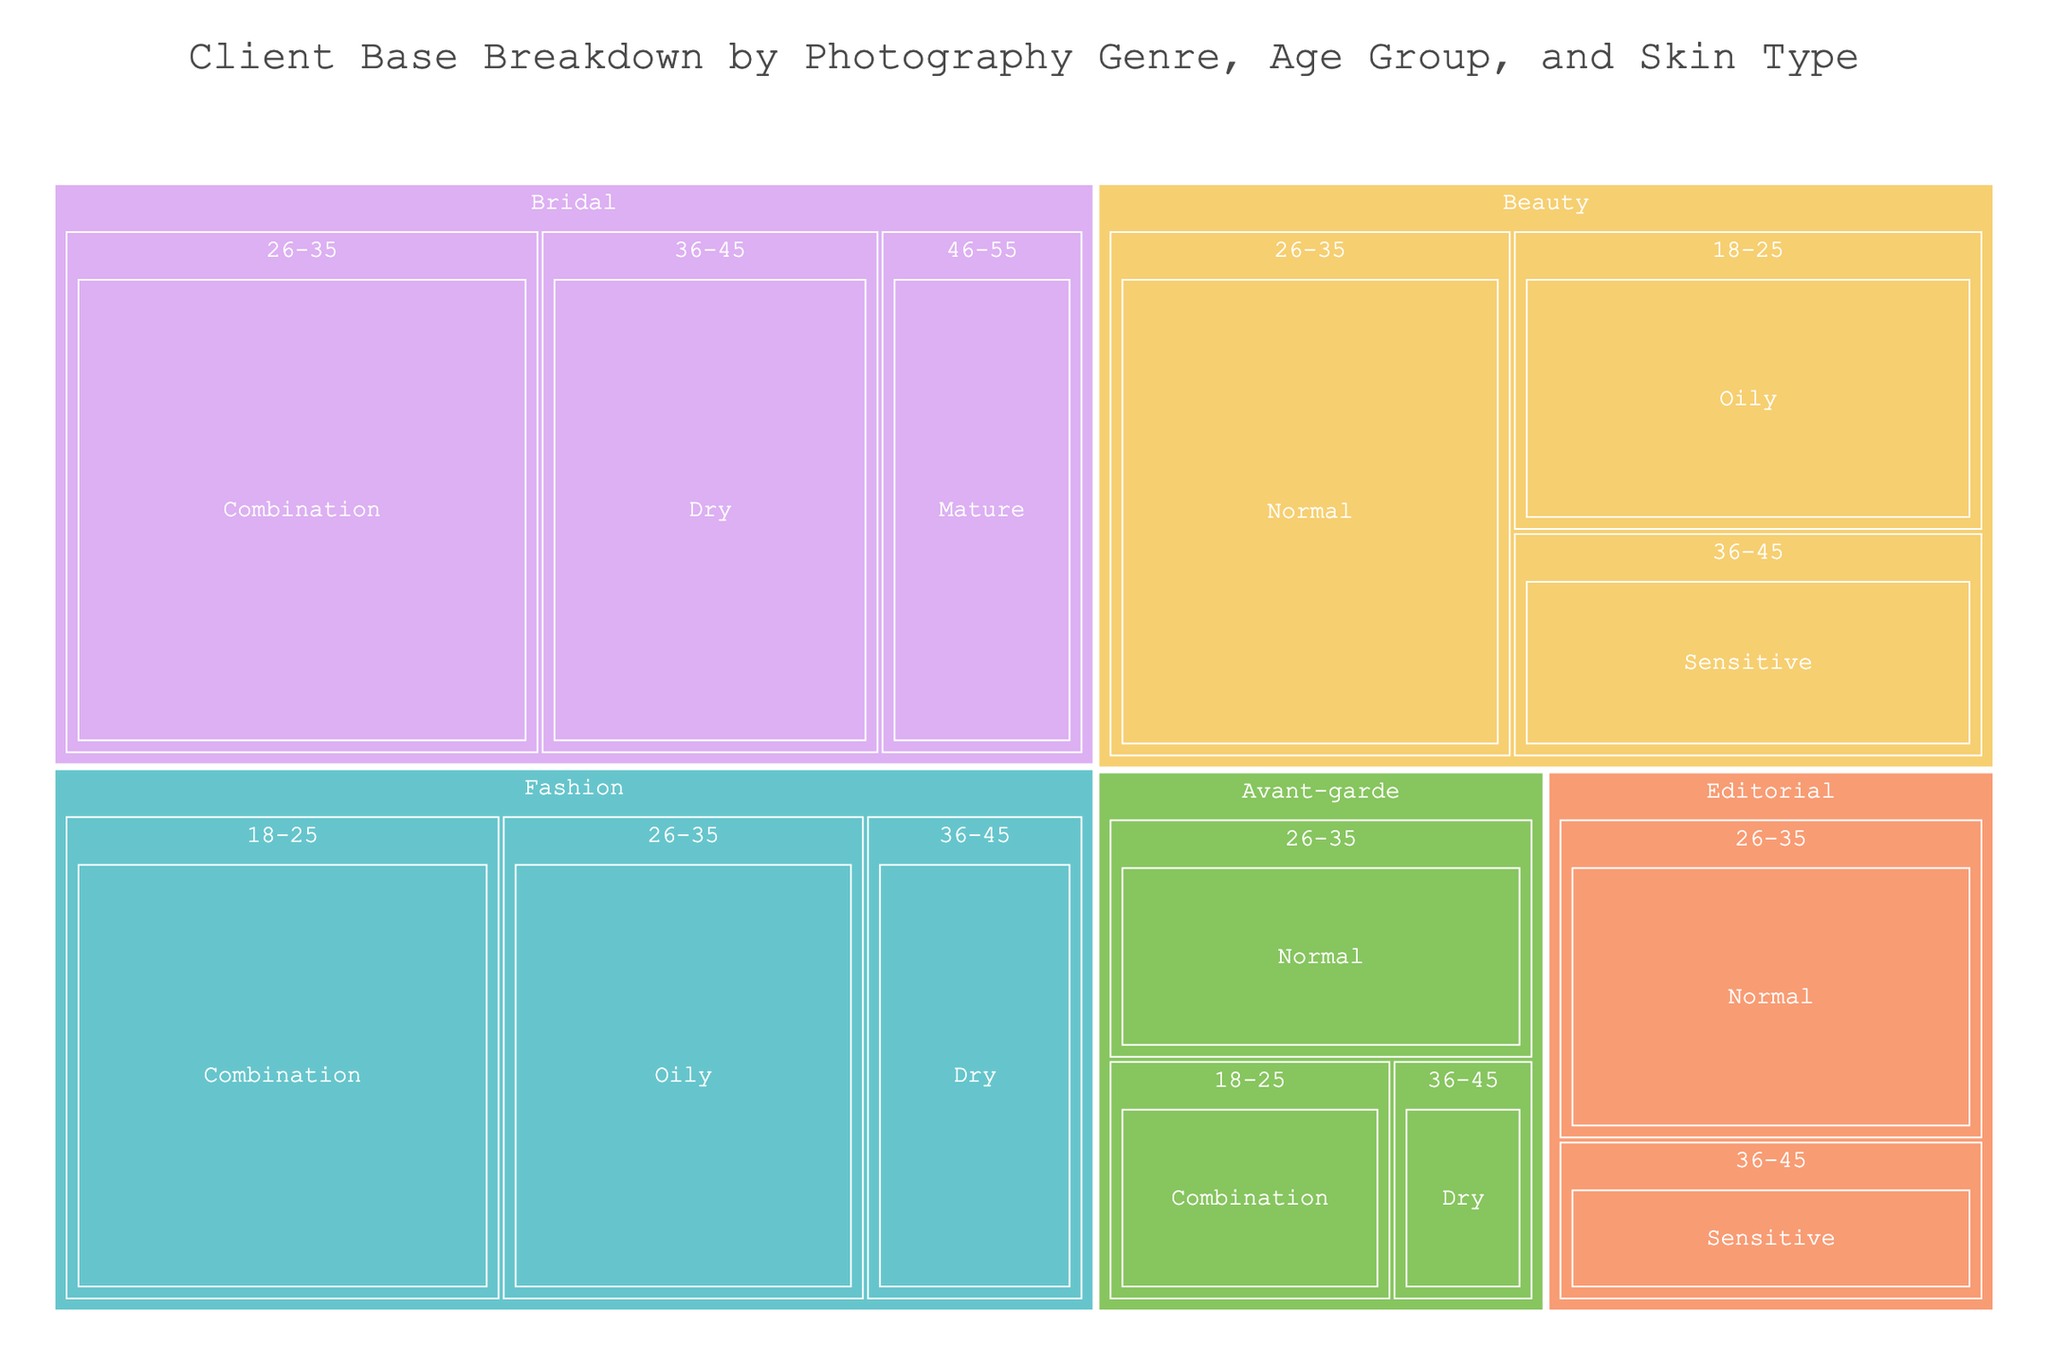What's the title of the treemap? The title is typically displayed at the top of the figure and gives a brief description of the chart's purpose or data coverage. Here, the title is displayed prominently in the center.
Answer: Client Base Breakdown by Photography Genre, Age Group, and Skin Type Which genre has the highest client base for the age group 26-35? To determine this, you can examine the treemap for all sections corresponding to the age group 26-35 and find the genre with the largest area.
Answer: Bridal What skin type is most common in the Bridal genre? In the Bridal genre section of the treemap, observe the area size associated with each skin type, and the one with the largest area corresponds to the most common skin type.
Answer: Combination How many clients fall into the Avant-garde genre for the age group 18-25? Locate the Avant-garde genre section, then specifically find the subsection labeled 18-25. The value displayed there represents the number of clients.
Answer: 10 Compare the number of clients in the Fashion genre with Oily skin type to those in Beauty genre with Sensitive skin type. Which is greater? Find the sections for Fashion with Oily skin type and Beauty with Sensitive skin type, then compare the values associated.
Answer: Fashion with Oily skin type What is the combined total number of clients in the 36-45 age group? Look at each genre that contains the 36-45 age group and sum up the values. (Fashion: 15, Editorial: 10, Bridal: 25, Beauty: 15, Avant-garde: 5)
Answer: 70 Which skin type appears most frequently across all genres? Review each genre and tally the occurrences of each skin type, then identify the one that has the highest total count across all genres.
Answer: Combination What's the total number of clients in the Fashion genre? Add up the values for all subcategories within the Fashion genre. (Fashion: 30 + 25 + 15)
Answer: 70 Compare the total number of clients in Editorial to the total in Beauty. Which is more? Calculate the sum of values in the Editorial genre (20 + 10) and Beauty genre (20 + 30 + 15), then compare the totals.
Answer: Beauty What's the average number of clients per skin type in the Bridal genre? Calculate the sum of values for each skin type in the Bridal genre and divide by the number of skin types (35 + 25 + 15) / 3
Answer: 25 